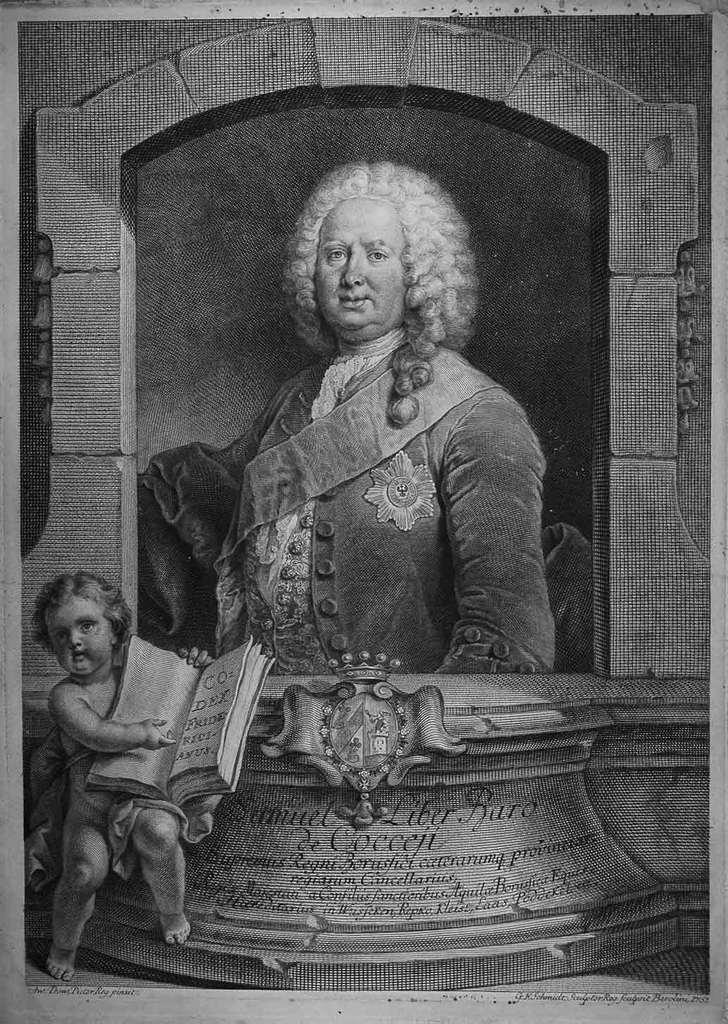How would you summarize this image in a sentence or two? In this image we can see picture of a person on the wall. On the left side we can see a kid holding a book and there is written on the platform. 